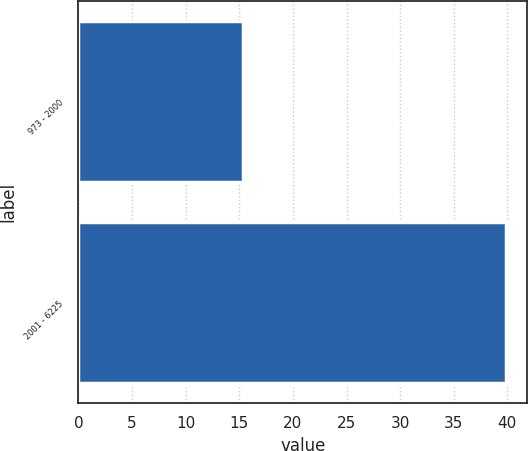Convert chart to OTSL. <chart><loc_0><loc_0><loc_500><loc_500><bar_chart><fcel>973 - 2000<fcel>2001 - 6225<nl><fcel>15.39<fcel>39.88<nl></chart> 